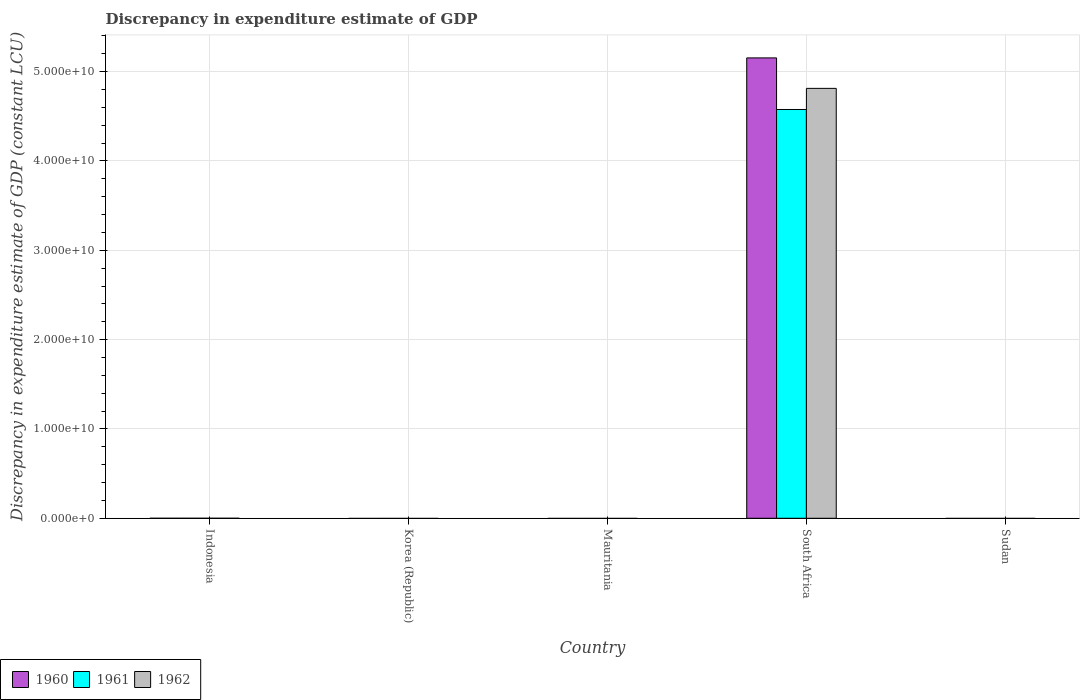Are the number of bars per tick equal to the number of legend labels?
Your answer should be compact. No. Are the number of bars on each tick of the X-axis equal?
Make the answer very short. No. In how many cases, is the number of bars for a given country not equal to the number of legend labels?
Offer a terse response. 4. Across all countries, what is the maximum discrepancy in expenditure estimate of GDP in 1961?
Give a very brief answer. 4.58e+1. Across all countries, what is the minimum discrepancy in expenditure estimate of GDP in 1961?
Give a very brief answer. 0. In which country was the discrepancy in expenditure estimate of GDP in 1960 maximum?
Ensure brevity in your answer.  South Africa. What is the total discrepancy in expenditure estimate of GDP in 1961 in the graph?
Provide a short and direct response. 4.58e+1. What is the difference between the discrepancy in expenditure estimate of GDP in 1961 in Mauritania and the discrepancy in expenditure estimate of GDP in 1960 in Indonesia?
Your answer should be compact. 0. What is the average discrepancy in expenditure estimate of GDP in 1960 per country?
Ensure brevity in your answer.  1.03e+1. What is the difference between the discrepancy in expenditure estimate of GDP of/in 1960 and discrepancy in expenditure estimate of GDP of/in 1962 in South Africa?
Keep it short and to the point. 3.41e+09. In how many countries, is the discrepancy in expenditure estimate of GDP in 1961 greater than 16000000000 LCU?
Your response must be concise. 1. What is the difference between the highest and the lowest discrepancy in expenditure estimate of GDP in 1960?
Your answer should be compact. 5.15e+1. Are all the bars in the graph horizontal?
Keep it short and to the point. No. How many countries are there in the graph?
Provide a succinct answer. 5. What is the difference between two consecutive major ticks on the Y-axis?
Give a very brief answer. 1.00e+1. Are the values on the major ticks of Y-axis written in scientific E-notation?
Provide a succinct answer. Yes. Does the graph contain any zero values?
Your response must be concise. Yes. Does the graph contain grids?
Make the answer very short. Yes. How many legend labels are there?
Your response must be concise. 3. What is the title of the graph?
Offer a very short reply. Discrepancy in expenditure estimate of GDP. Does "2014" appear as one of the legend labels in the graph?
Provide a short and direct response. No. What is the label or title of the X-axis?
Provide a succinct answer. Country. What is the label or title of the Y-axis?
Give a very brief answer. Discrepancy in expenditure estimate of GDP (constant LCU). What is the Discrepancy in expenditure estimate of GDP (constant LCU) in 1962 in Indonesia?
Your answer should be very brief. 0. What is the Discrepancy in expenditure estimate of GDP (constant LCU) in 1960 in Korea (Republic)?
Provide a succinct answer. 0. What is the Discrepancy in expenditure estimate of GDP (constant LCU) in 1961 in Korea (Republic)?
Your answer should be compact. 0. What is the Discrepancy in expenditure estimate of GDP (constant LCU) in 1962 in Korea (Republic)?
Ensure brevity in your answer.  0. What is the Discrepancy in expenditure estimate of GDP (constant LCU) of 1961 in Mauritania?
Your answer should be very brief. 0. What is the Discrepancy in expenditure estimate of GDP (constant LCU) of 1962 in Mauritania?
Your response must be concise. 0. What is the Discrepancy in expenditure estimate of GDP (constant LCU) of 1960 in South Africa?
Your answer should be very brief. 5.15e+1. What is the Discrepancy in expenditure estimate of GDP (constant LCU) in 1961 in South Africa?
Keep it short and to the point. 4.58e+1. What is the Discrepancy in expenditure estimate of GDP (constant LCU) in 1962 in South Africa?
Offer a very short reply. 4.81e+1. What is the Discrepancy in expenditure estimate of GDP (constant LCU) of 1960 in Sudan?
Your answer should be very brief. 0. What is the Discrepancy in expenditure estimate of GDP (constant LCU) in 1962 in Sudan?
Provide a short and direct response. 0. Across all countries, what is the maximum Discrepancy in expenditure estimate of GDP (constant LCU) of 1960?
Give a very brief answer. 5.15e+1. Across all countries, what is the maximum Discrepancy in expenditure estimate of GDP (constant LCU) in 1961?
Offer a terse response. 4.58e+1. Across all countries, what is the maximum Discrepancy in expenditure estimate of GDP (constant LCU) of 1962?
Provide a short and direct response. 4.81e+1. Across all countries, what is the minimum Discrepancy in expenditure estimate of GDP (constant LCU) in 1960?
Your answer should be compact. 0. Across all countries, what is the minimum Discrepancy in expenditure estimate of GDP (constant LCU) of 1961?
Provide a succinct answer. 0. What is the total Discrepancy in expenditure estimate of GDP (constant LCU) of 1960 in the graph?
Give a very brief answer. 5.15e+1. What is the total Discrepancy in expenditure estimate of GDP (constant LCU) of 1961 in the graph?
Give a very brief answer. 4.58e+1. What is the total Discrepancy in expenditure estimate of GDP (constant LCU) of 1962 in the graph?
Provide a succinct answer. 4.81e+1. What is the average Discrepancy in expenditure estimate of GDP (constant LCU) of 1960 per country?
Your answer should be very brief. 1.03e+1. What is the average Discrepancy in expenditure estimate of GDP (constant LCU) in 1961 per country?
Provide a succinct answer. 9.15e+09. What is the average Discrepancy in expenditure estimate of GDP (constant LCU) in 1962 per country?
Offer a terse response. 9.62e+09. What is the difference between the Discrepancy in expenditure estimate of GDP (constant LCU) in 1960 and Discrepancy in expenditure estimate of GDP (constant LCU) in 1961 in South Africa?
Your response must be concise. 5.78e+09. What is the difference between the Discrepancy in expenditure estimate of GDP (constant LCU) in 1960 and Discrepancy in expenditure estimate of GDP (constant LCU) in 1962 in South Africa?
Provide a succinct answer. 3.41e+09. What is the difference between the Discrepancy in expenditure estimate of GDP (constant LCU) in 1961 and Discrepancy in expenditure estimate of GDP (constant LCU) in 1962 in South Africa?
Give a very brief answer. -2.37e+09. What is the difference between the highest and the lowest Discrepancy in expenditure estimate of GDP (constant LCU) of 1960?
Offer a terse response. 5.15e+1. What is the difference between the highest and the lowest Discrepancy in expenditure estimate of GDP (constant LCU) in 1961?
Your answer should be very brief. 4.58e+1. What is the difference between the highest and the lowest Discrepancy in expenditure estimate of GDP (constant LCU) of 1962?
Give a very brief answer. 4.81e+1. 